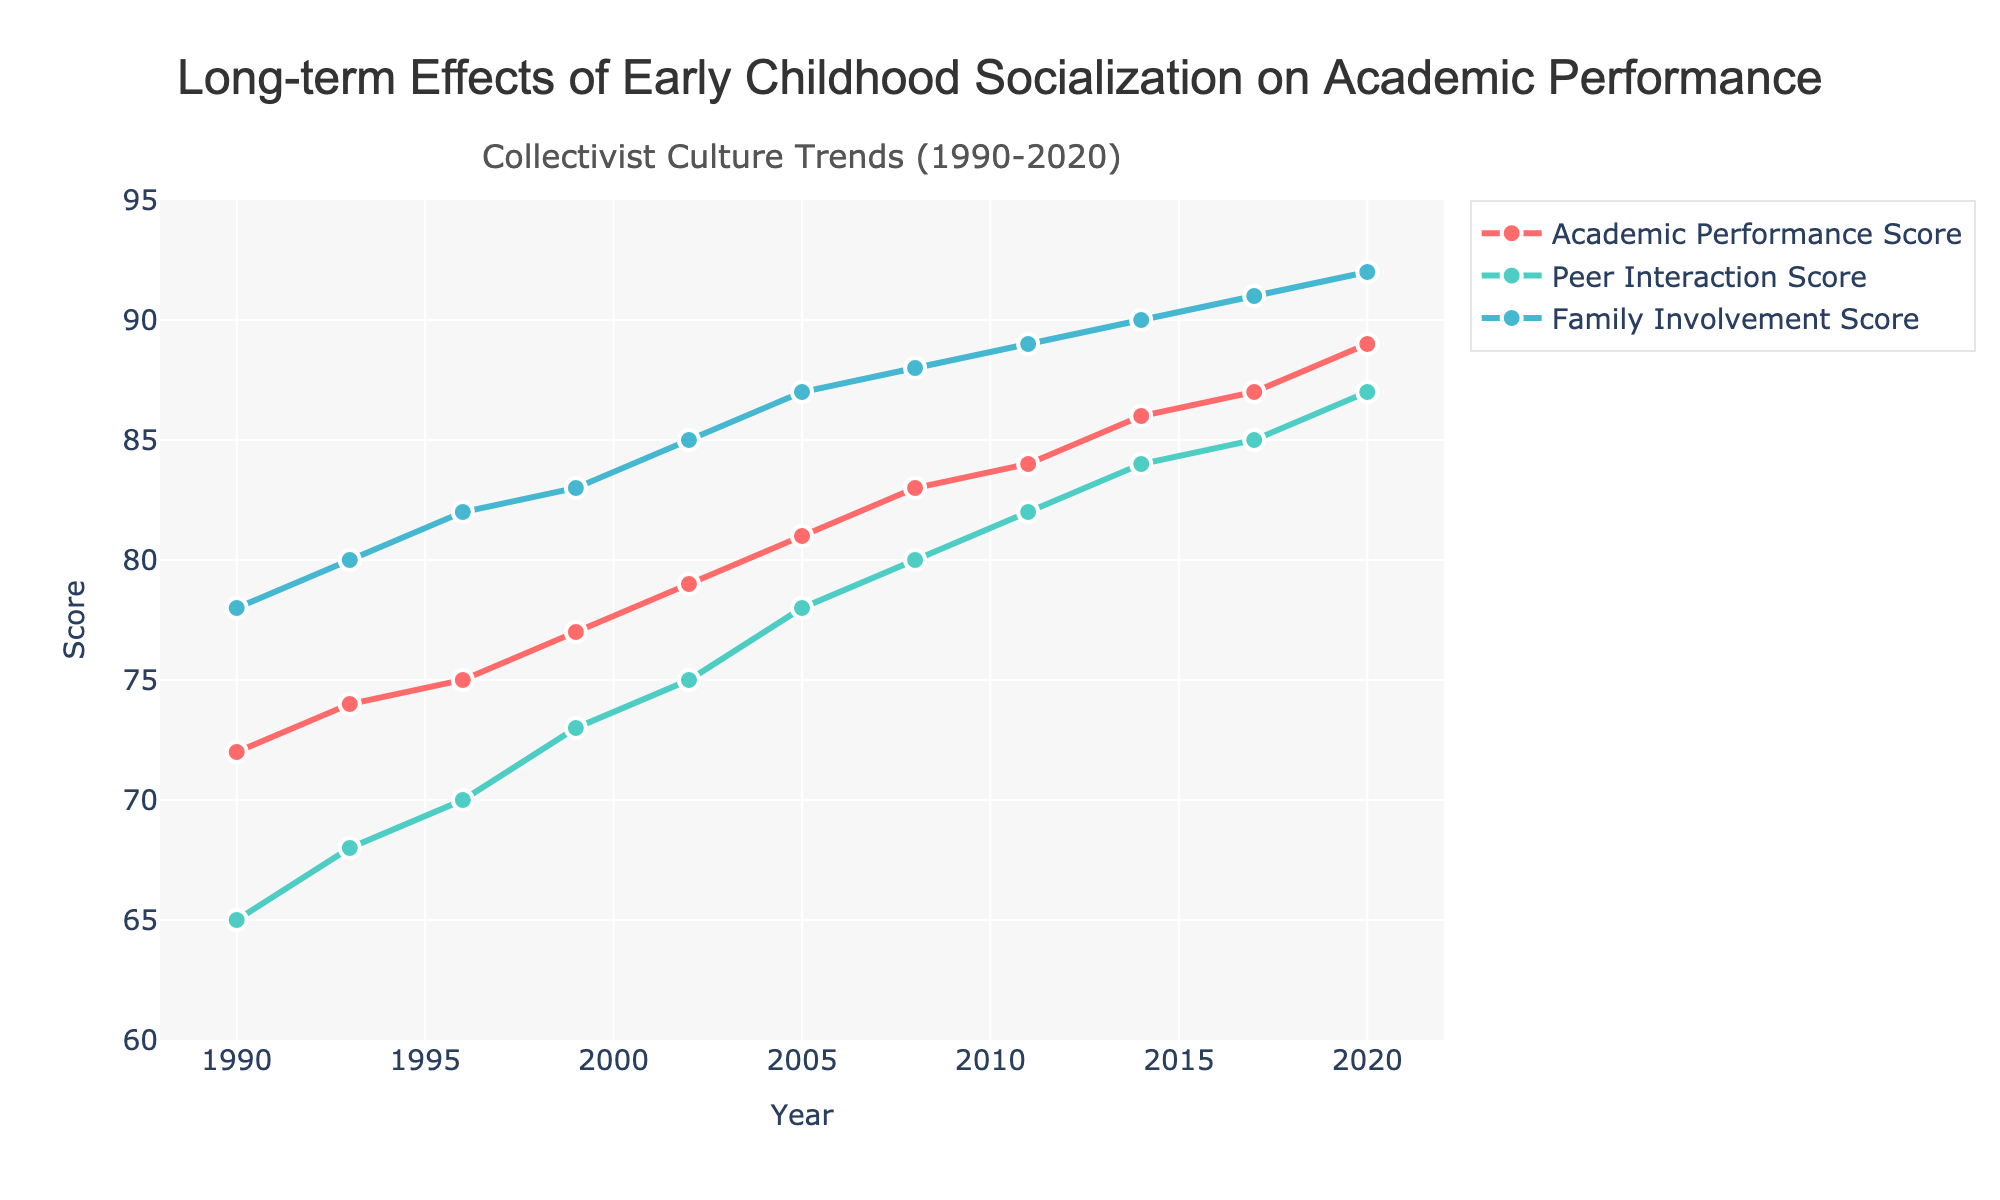What's the overall trend in the Academic Performance Score from 1990 to 2020? From 1990 to 2020, the Academic Performance Score shows a consistent upward trend from 72 to 89. This indicates that academic performance has improved over the years.
Answer: Increase How does Family Involvement Score compare to Academic Performance Score in the year 2005? In 2005, the Family Involvement Score is 87, while the Academic Performance Score is 81. Hence, the Family Involvement Score is higher than the Academic Performance Score by 6 points.
Answer: Higher Which year shows the highest Peer Interaction Score, and what is the score? The highest Peer Interaction Score is in the year 2020, and the score is 87.
Answer: 2020, 87 What is the difference in the Peer Interaction Score between 1993 and 2014? The Peer Interaction Score in 1993 is 68, and in 2014 it is 84. The difference between these scores is 84 - 68 = 16.
Answer: 16 Calculate the average Academic Performance Score from 1990 to 2020. To calculate the average, sum all the Academic Performance Scores from 1990 to 2020 and divide by the number of years. (72 + 74 + 75 + 77 + 79 + 81 + 83 + 84 + 86 + 87 + 89) / 11 = 887 / 11 ≈ 80.64
Answer: ~80.64 Between which consecutive years does the Family Involvement Score show the largest increase? By calculating the difference between consecutive years, the largest increase for Family Involvement Score is from 1990 to 1993, where it increases from 78 to 80, an increase of 2 points. All other increases between consecutive years are either 1 or no increase.
Answer: 1990-1993 What is the ratio of the Academic Performance Score to the Peer Interaction Score in the year 2011? In 2011, the Academic Performance Score is 84 and the Peer Interaction Score is 82. The ratio is calculated as 84 / 82 = 1.0244.
Answer: ~1.0244 Compare the trend lines of Peer Interaction Score and Family Involvement Score from 2002 to 2020. Which had a steeper increase? Both scores trend upward from 2002 to 2020. The Peer Interaction Score increases from 75 to 87 (12 points), and the Family Involvement Score increases from 85 to 92 (7 points). The Peer Interaction Score shows a steeper increase.
Answer: Peer Interaction Score Is there any year between 1990 and 2020 where the three scores are equal? Looking at the data for each year, none of the years have equal values for Academic Performance, Peer Interaction, and Family Involvement Scores.
Answer: No 